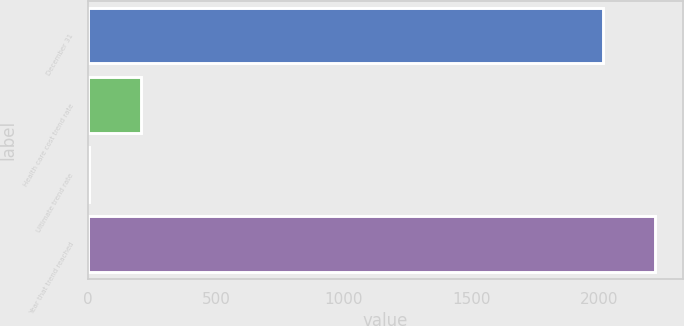Convert chart to OTSL. <chart><loc_0><loc_0><loc_500><loc_500><bar_chart><fcel>December 31<fcel>Health care cost trend rate<fcel>Ultimate trend rate<fcel>Year that trend reached<nl><fcel>2015<fcel>206.6<fcel>5<fcel>2216.6<nl></chart> 